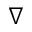Convert formula to latex. <formula><loc_0><loc_0><loc_500><loc_500>\nabla</formula> 